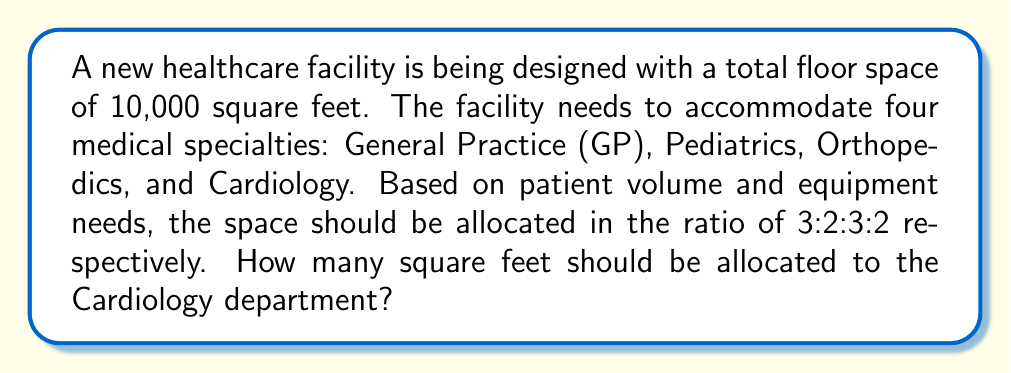Give your solution to this math problem. Let's approach this step-by-step:

1) First, we need to understand what the ratio 3:2:3:2 means for our four specialties:
   GP : Pediatrics : Orthopedics : Cardiology
   3  :     2      :     3       :    2

2) To find the total parts, we sum the ratio numbers:
   $3 + 2 + 3 + 2 = 10$ parts in total

3) Now, we can set up an equation:
   Let $x$ be the square footage for 1 part.
   Then, $10x = 10,000$ (total square footage)

4) Solve for $x$:
   $x = 10,000 \div 10 = 1,000$ sq ft per part

5) The Cardiology department is allocated 2 parts in the ratio.
   So, its square footage will be:
   $2 * 1,000 = 2,000$ sq ft

Therefore, the Cardiology department should be allocated 2,000 square feet.
Answer: 2,000 sq ft 